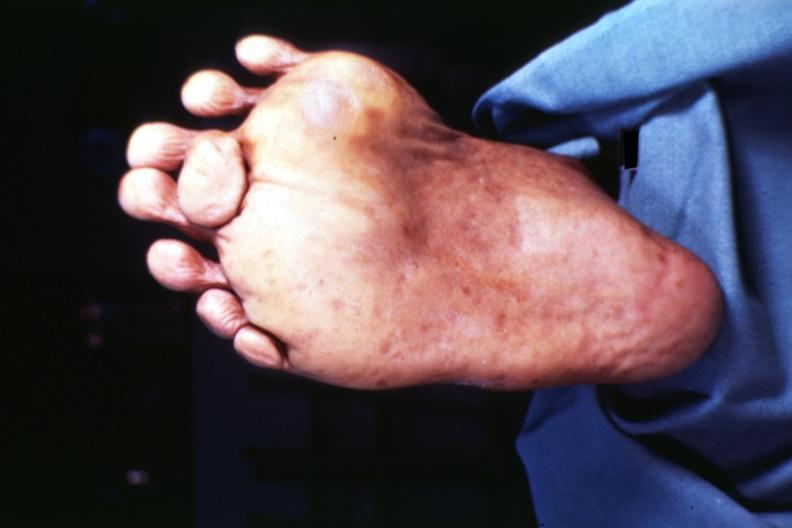does fixed tissue show view of foot from plantar surface 7 toes at least?
Answer the question using a single word or phrase. No 